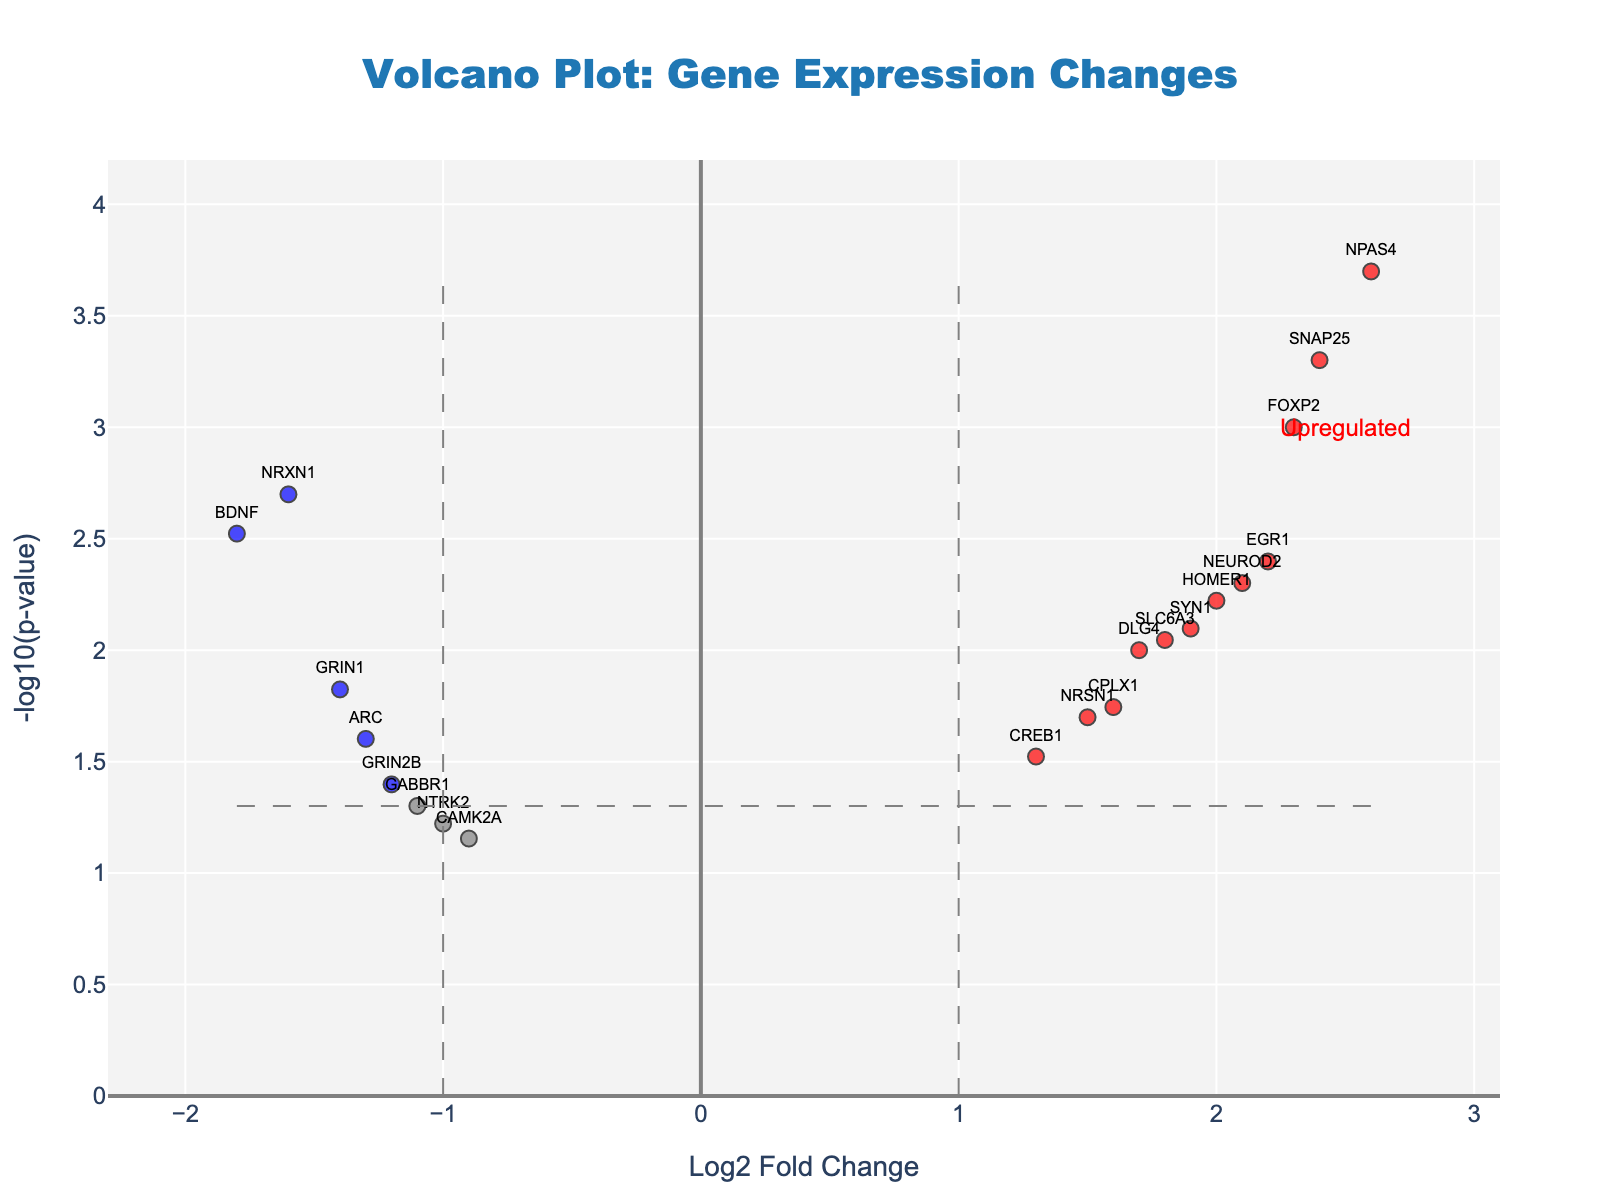What is the title of the figure? The title of the figure is always prominently displayed at the top and is often in a larger or bold font to distinguish it from other text and elements.
Answer: Volcano Plot: Gene Expression Changes What are the labels of the x-axis and the y-axis? The labels of the axes are mentioned along the respective axes to indicate the type of data plotted. The x-axis typically lies horizontally, whereas the y-axis runs vertically.
Answer: The x-axis label is "Log2 Fold Change" and the y-axis label is "-log10(p-value)" How many genes are significantly upregulated (marked in red)? Significantly upregulated genes are marked in red color. To determine the number, count the number of red points scattered to the right side of the plot, representing the positive Log2 Fold Change and low p-value.
Answer: 6 Which gene shows the highest level of upregulation? By examining the plot, we find the red point that is furthest to the right on the x-axis, which signifies the highest Log2 Fold Change value. The gene label next to this point identifies the gene.
Answer: NPAS4 For the gene with the highest level of upregulation, what is its Log2 Fold Change and p-value? By locating the position of NPAS4 on the plot, the Log2 Fold Change is read from the x-axis and the p-value from the y-axis, or by referring to the hover text displayed on the plot for more accurate values.
Answer: Log2 Fold Change: 2.6, p-value: 0.0002 Compare the number of significantly downregulated genes (blue points) to the number of significantly upregulated genes (red points). Which are more? First count the number of blue points (downregulated genes) and red points (upregulated genes). Comparing these two counts will tell us which category has more genes.
Answer: There are more significantly upregulated genes Identify the gene with the lowest p-value. How is it classified based on fold change? Locate the datapoint with the highest value on the y-axis, representing the lowest p-value. Classify the gene based on its position on the x-axis, whether it is positive (upregulated) or negative (downregulated).
Answer: SNAP25, significantly upregulated What does the color gray indicate about the points on the plot? Gray points typically indicate genes that do not meet the significance threshold for either Log2 Fold Change or p-value. These are points outside of the color-coded significance regions on the plot.
Answer: Non-significant gene expression Name two genes that are significantly downregulated. Identify blue points (indicating downregulation) on the plot. The gene labels next to these blue points reveal the names of the downregulated genes.
Answer: BDNF, NRXN1 What is the significance threshold for the Log2 Fold Change and p-value in this plot? Threshold lines specifying significance are plotted and can be read from the plot. Log2 Fold Change thresholds typically correspond to vertical dashed lines, whereas the p-value threshold corresponds to a horizontal dashed line.
Answer: Log2 Fold Change: ±1, p-value: 0.05 